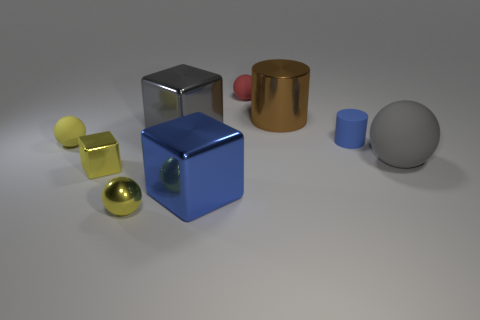Subtract all tiny blocks. How many blocks are left? 2 Subtract all green cylinders. How many yellow blocks are left? 1 Subtract all blue blocks. Subtract all tiny blue things. How many objects are left? 7 Add 1 yellow metallic things. How many yellow metallic things are left? 3 Add 8 gray spheres. How many gray spheres exist? 9 Subtract all gray balls. How many balls are left? 3 Subtract 0 green cubes. How many objects are left? 9 Subtract all cubes. How many objects are left? 6 Subtract 1 cylinders. How many cylinders are left? 1 Subtract all brown spheres. Subtract all purple blocks. How many spheres are left? 4 